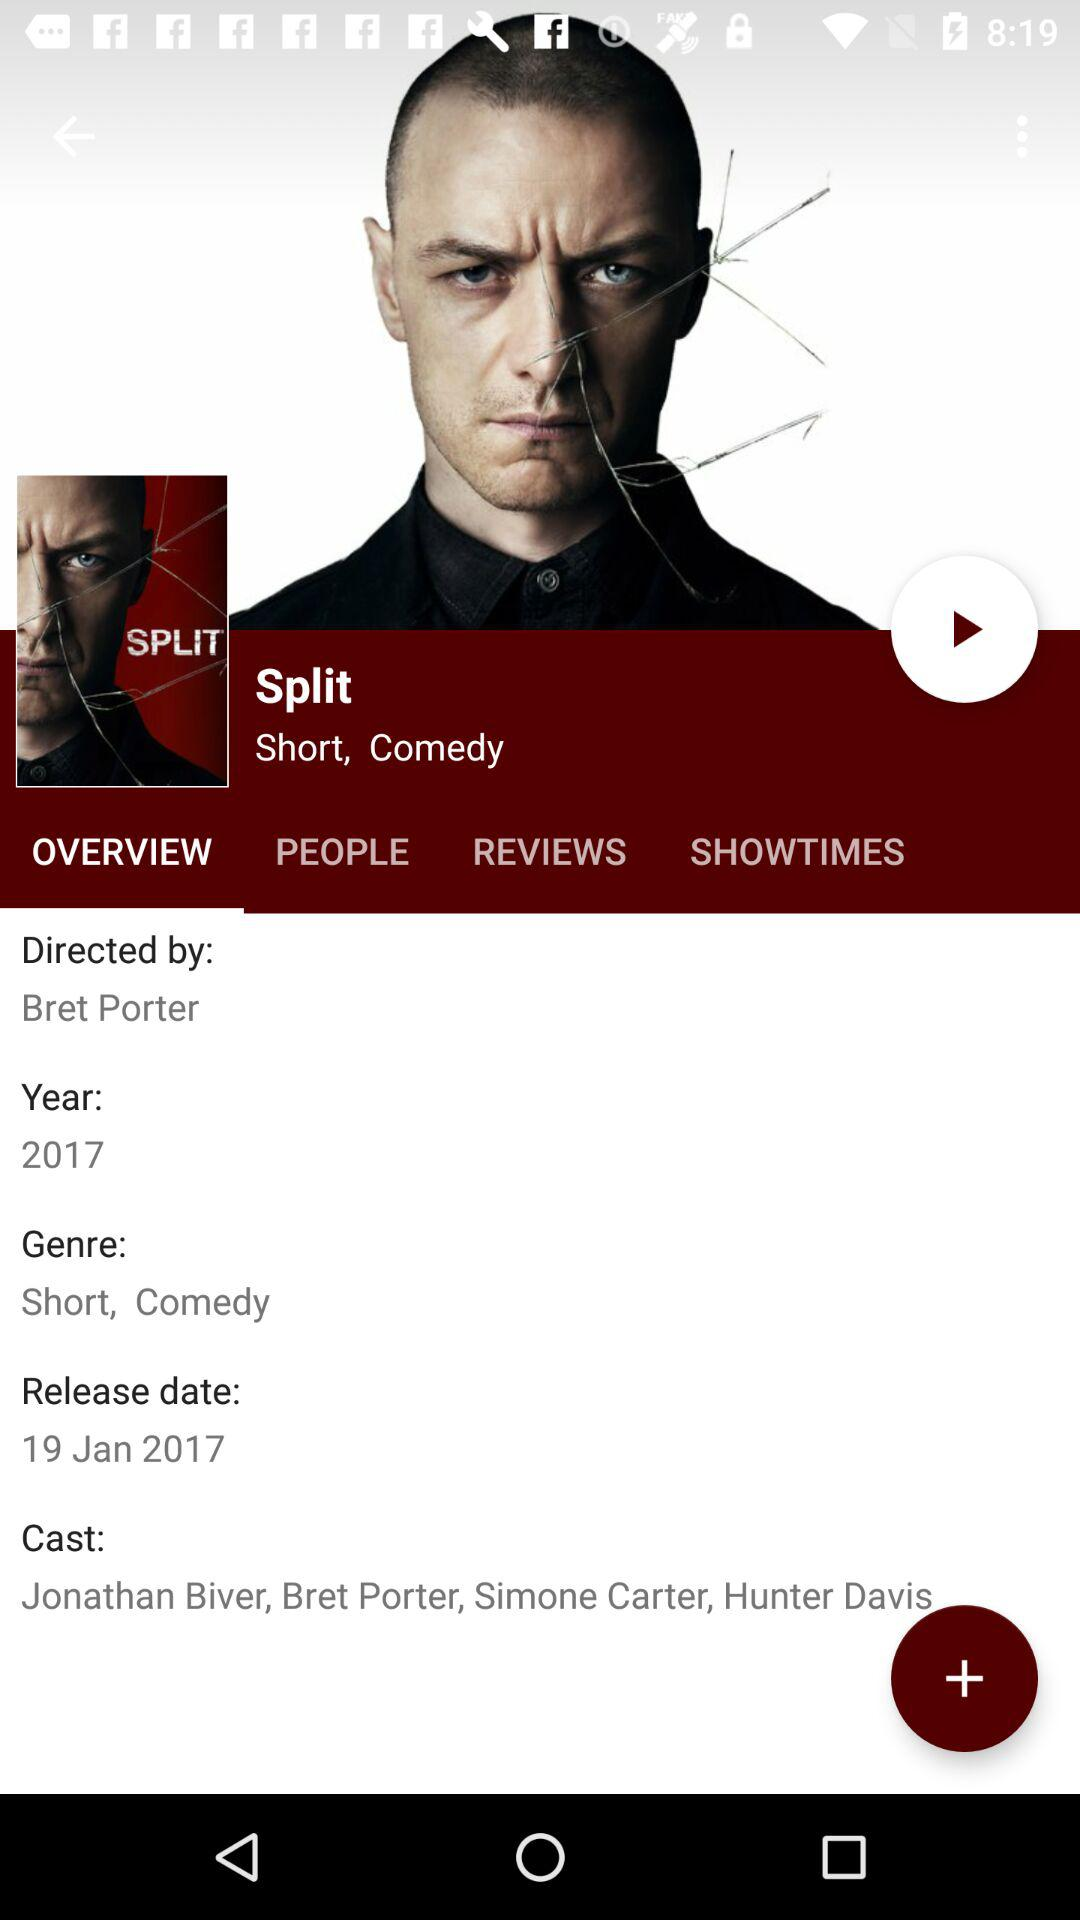What is the type of film? The types of films are "short" and "comedy". 